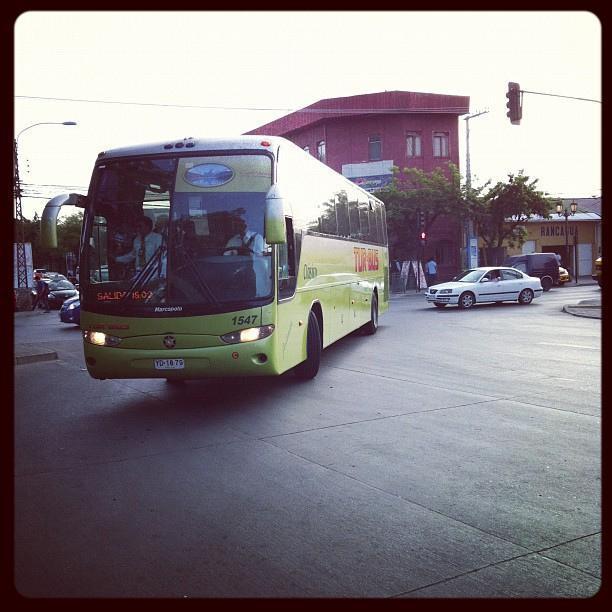How many orange papers are on the toilet?
Give a very brief answer. 0. 